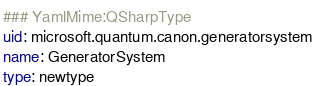Convert code to text. <code><loc_0><loc_0><loc_500><loc_500><_YAML_>### YamlMime:QSharpType
uid: microsoft.quantum.canon.generatorsystem
name: GeneratorSystem
type: newtype</code> 